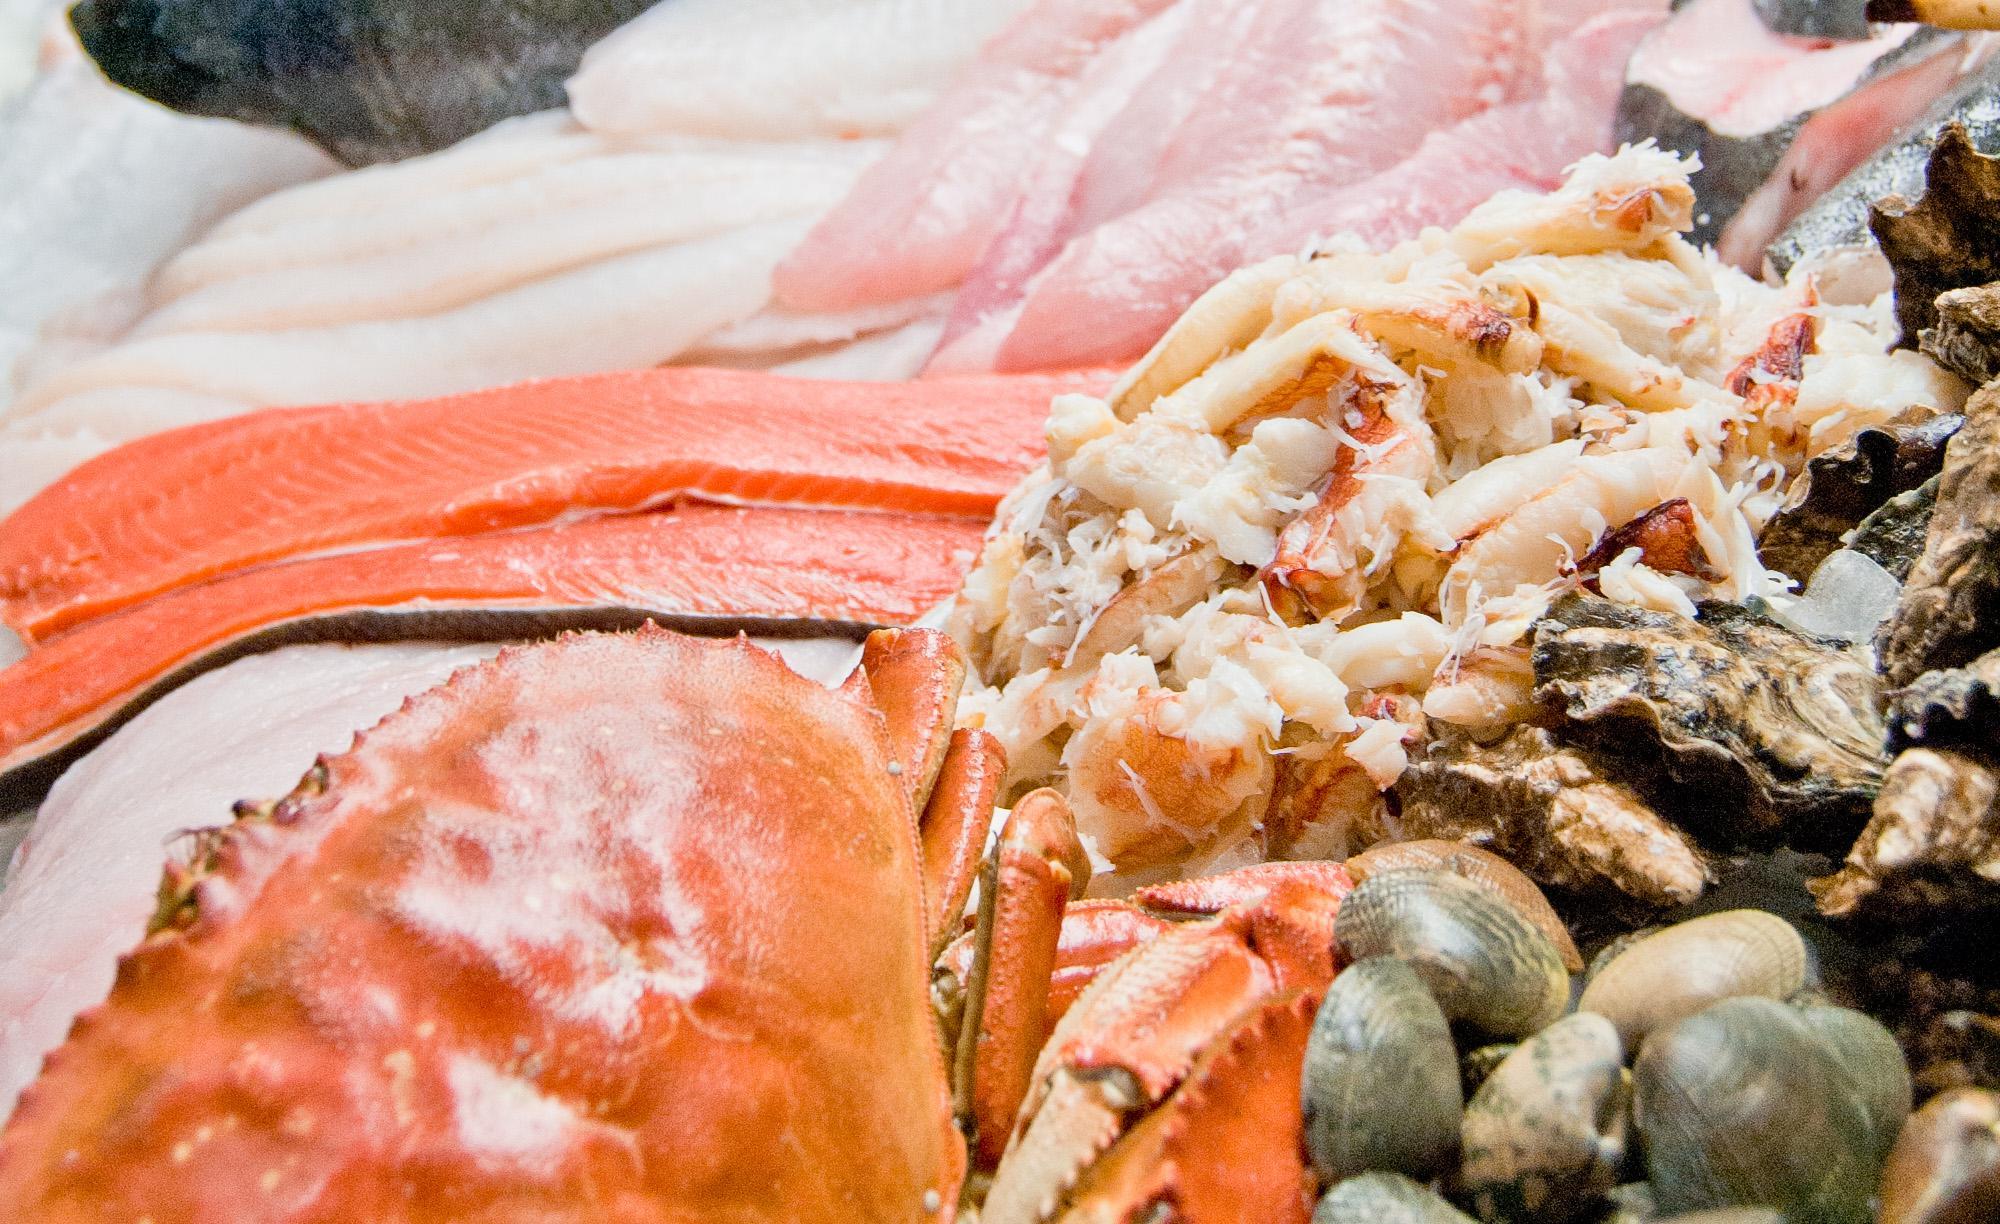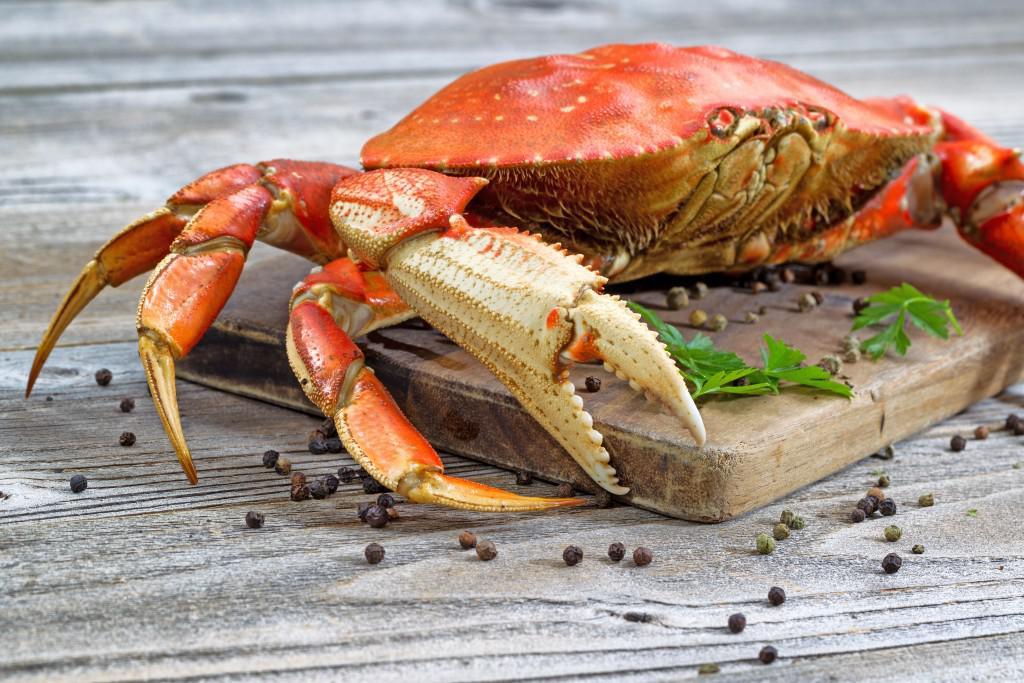The first image is the image on the left, the second image is the image on the right. Examine the images to the left and right. Is the description "The left image is a top-view of a pile of blue-gray crabs, and the right image is a more head-on view of multiple red-orange crabs." accurate? Answer yes or no. No. The first image is the image on the left, the second image is the image on the right. Evaluate the accuracy of this statement regarding the images: "There is one pile of gray crabs and one pile of red crabs.". Is it true? Answer yes or no. No. 